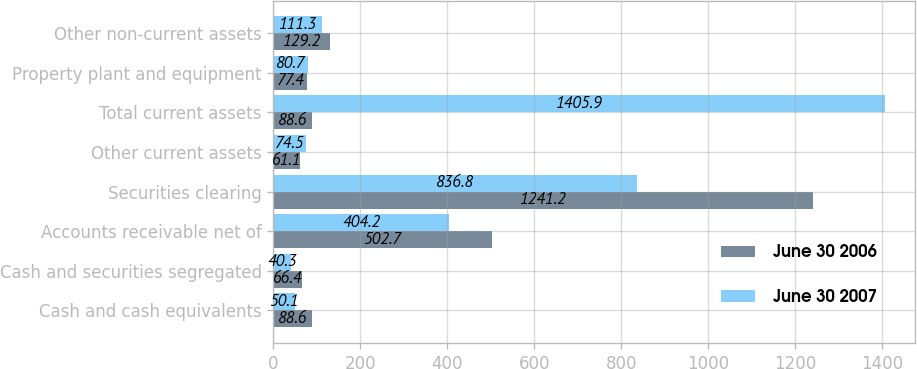Convert chart. <chart><loc_0><loc_0><loc_500><loc_500><stacked_bar_chart><ecel><fcel>Cash and cash equivalents<fcel>Cash and securities segregated<fcel>Accounts receivable net of<fcel>Securities clearing<fcel>Other current assets<fcel>Total current assets<fcel>Property plant and equipment<fcel>Other non-current assets<nl><fcel>June 30 2006<fcel>88.6<fcel>66.4<fcel>502.7<fcel>1241.2<fcel>61.1<fcel>88.6<fcel>77.4<fcel>129.2<nl><fcel>June 30 2007<fcel>50.1<fcel>40.3<fcel>404.2<fcel>836.8<fcel>74.5<fcel>1405.9<fcel>80.7<fcel>111.3<nl></chart> 